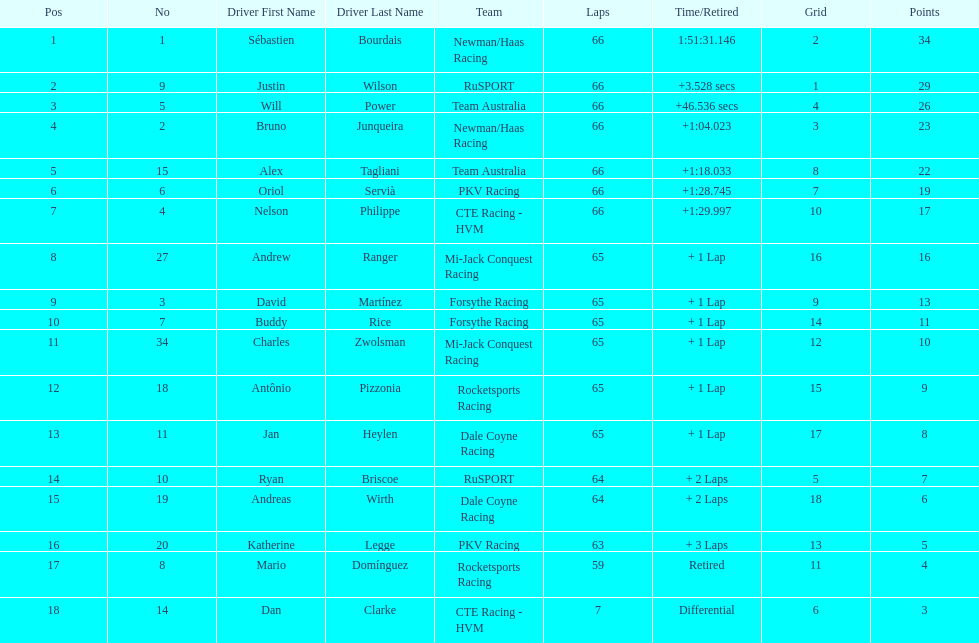At the 2006 gran premio telmex, who finished last? Dan Clarke. 